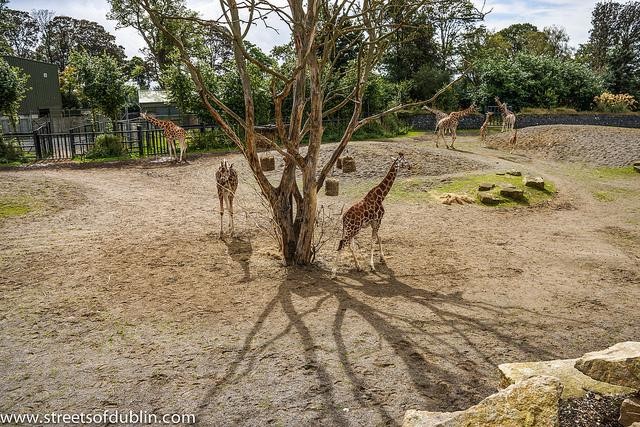What are the giraffes near?

Choices:
A) boats
B) pumpkins
C) trees
D) cows trees 